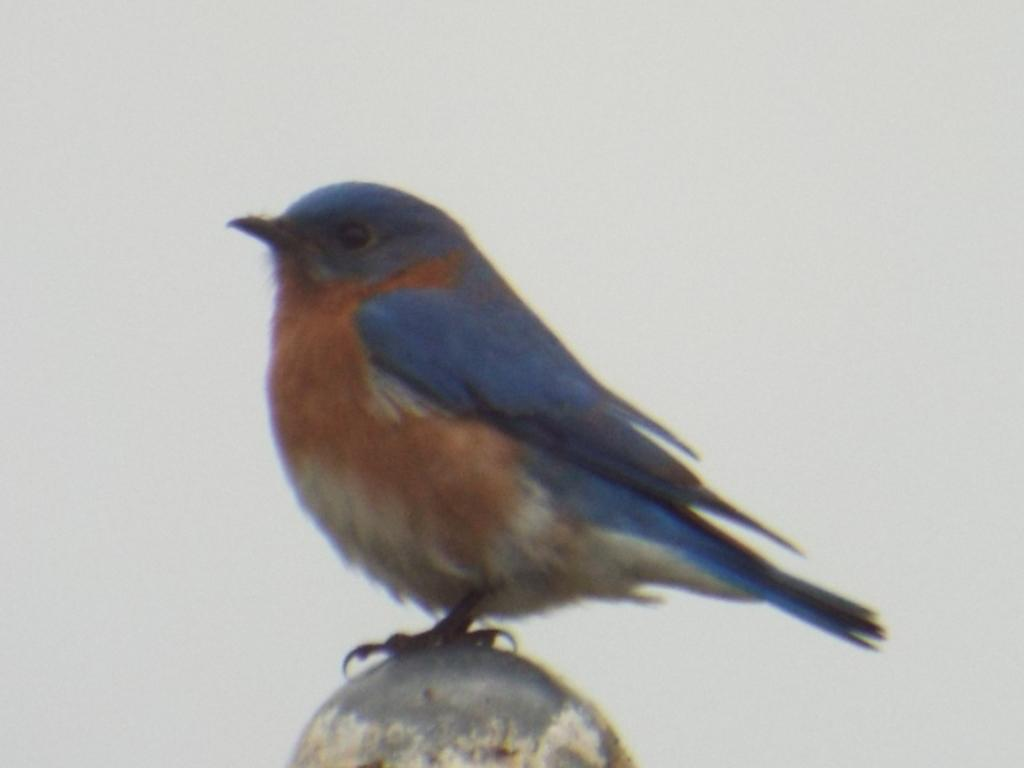What type of animal can be seen in the image? There is a bird in the image. Where is the bird located in the image? The bird is on a circular shaped object. What color is the background of the image? The background of the image is white in color. How many oranges are being held by the bird's tongue in the image? There are no oranges or tongues visible in the image; it features a bird on a circular object with a white background. 